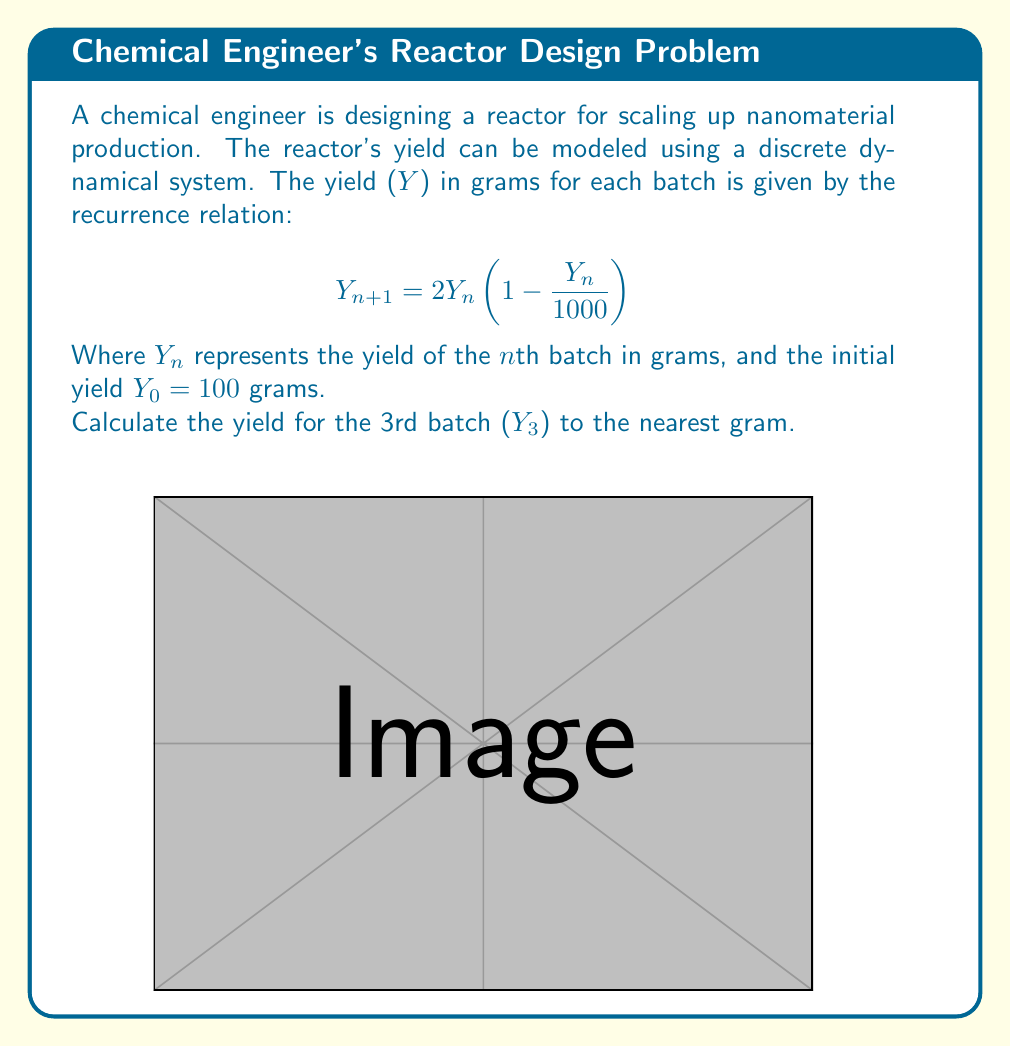Help me with this question. Let's solve this step-by-step:

1) We start with $Y_0 = 100$ grams.

2) To find $Y_1$, we use the given formula:
   $$Y_1 = 2Y_0(1 - \frac{Y_0}{1000})$$
   $$Y_1 = 2(100)(1 - \frac{100}{1000}) = 200(0.9) = 180$$ grams

3) For $Y_2$:
   $$Y_2 = 2Y_1(1 - \frac{Y_1}{1000})$$
   $$Y_2 = 2(180)(1 - \frac{180}{1000}) = 360(0.82) = 295.2$$ grams

4) Finally, for $Y_3$:
   $$Y_3 = 2Y_2(1 - \frac{Y_2}{1000})$$
   $$Y_3 = 2(295.2)(1 - \frac{295.2}{1000})$$
   $$Y_3 = 590.4(0.7048) = 416.11968$$ grams

5) Rounding to the nearest gram:
   $Y_3 \approx 416$ grams

This discrete dynamical system models the reactor's yield, taking into account factors that might limit growth as the yield increases, such as resource limitations or reactor capacity.
Answer: 416 grams 